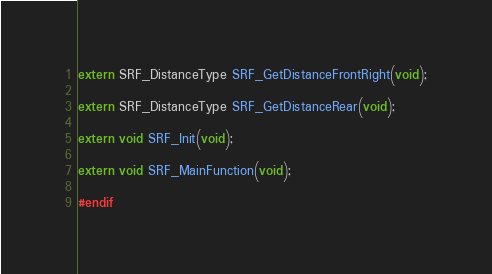<code> <loc_0><loc_0><loc_500><loc_500><_C_>extern SRF_DistanceType SRF_GetDistanceFrontRight(void);

extern SRF_DistanceType SRF_GetDistanceRear(void);

extern void SRF_Init(void);

extern void SRF_MainFunction(void);

#endif
</code> 